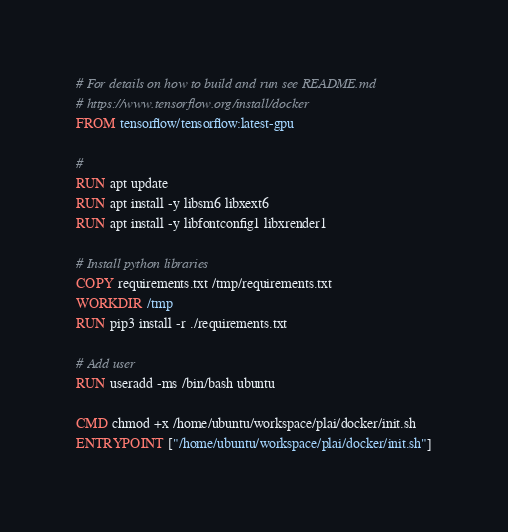Convert code to text. <code><loc_0><loc_0><loc_500><loc_500><_Dockerfile_># For details on how to build and run see README.md
# https://www.tensorflow.org/install/docker
FROM tensorflow/tensorflow:latest-gpu

# 
RUN apt update 
RUN apt install -y libsm6 libxext6
RUN apt install -y libfontconfig1 libxrender1

# Install python libraries
COPY requirements.txt /tmp/requirements.txt
WORKDIR /tmp
RUN pip3 install -r ./requirements.txt

# Add user
RUN useradd -ms /bin/bash ubuntu

CMD chmod +x /home/ubuntu/workspace/plai/docker/init.sh
ENTRYPOINT ["/home/ubuntu/workspace/plai/docker/init.sh"]</code> 